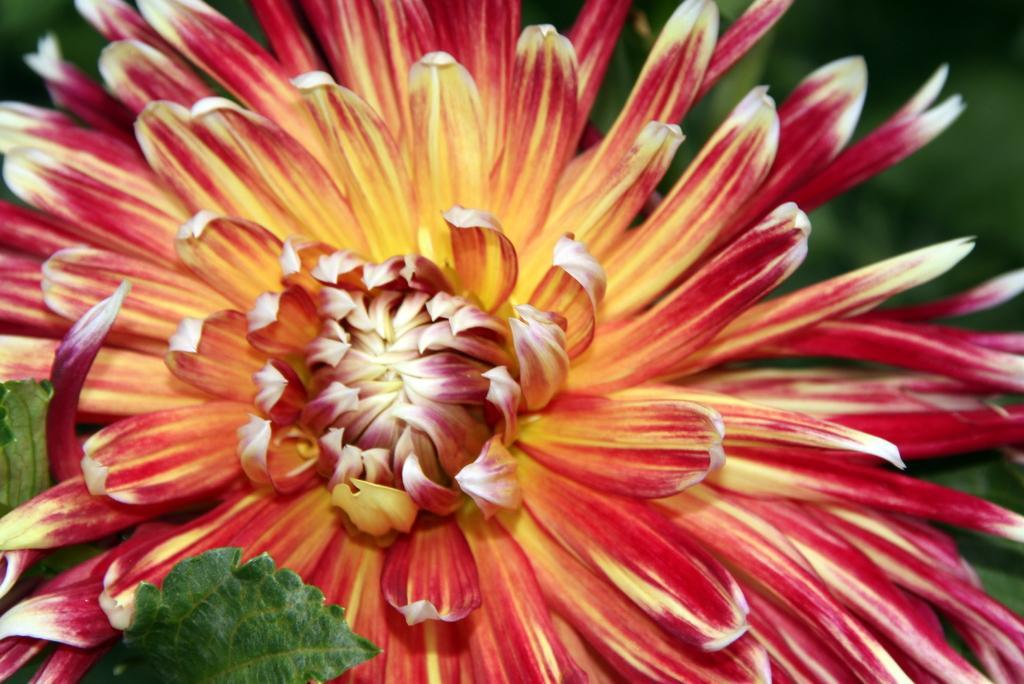Could you give a brief overview of what you see in this image? In this image we can see a flower. We can also see some leaves. 